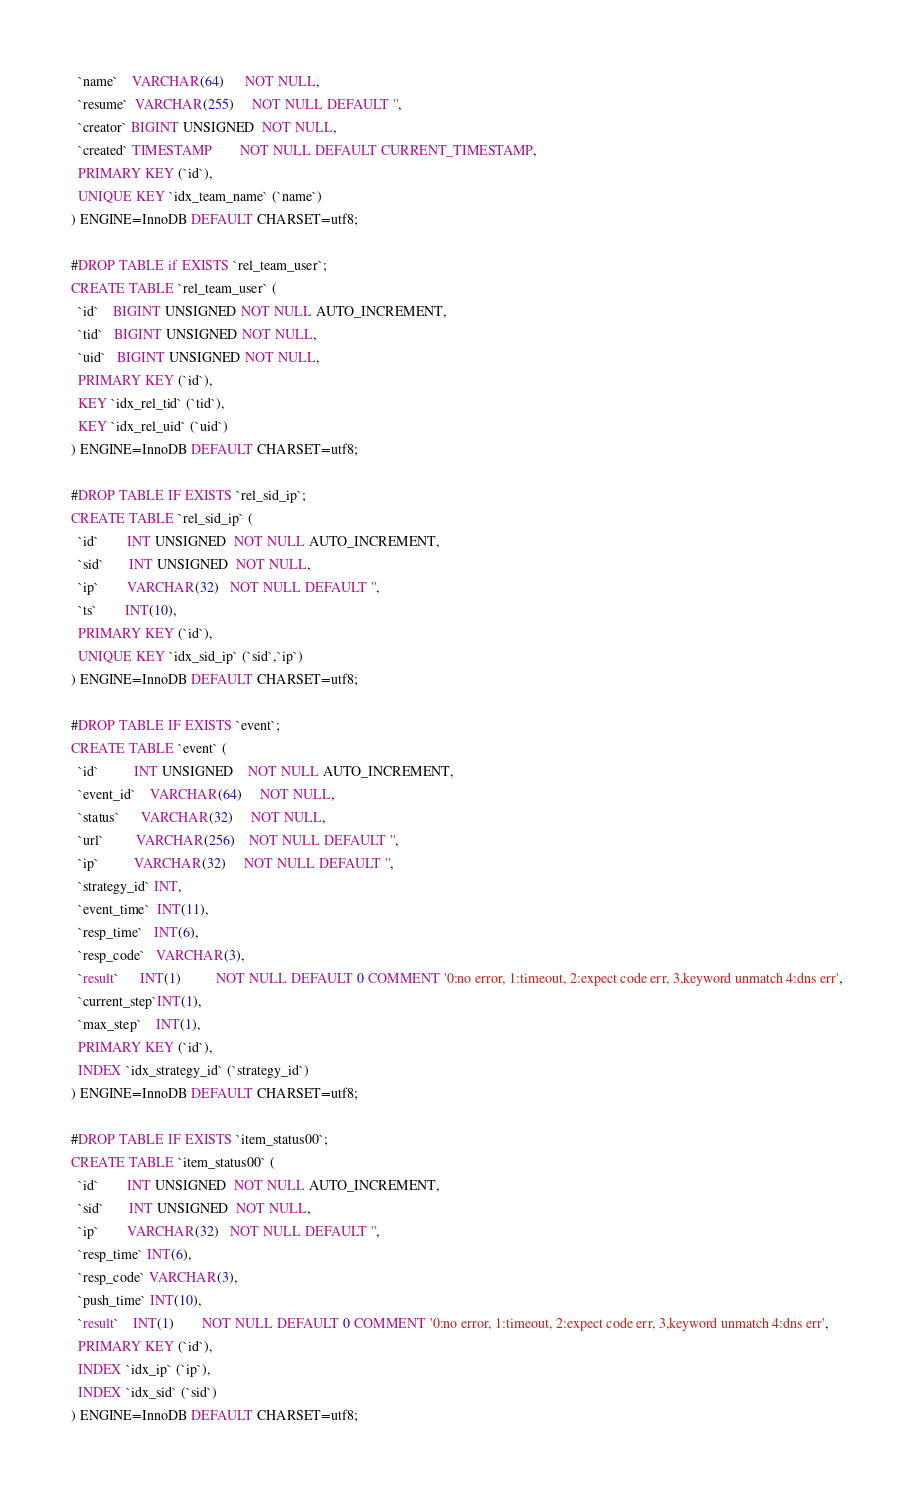Convert code to text. <code><loc_0><loc_0><loc_500><loc_500><_SQL_>  `name`    VARCHAR(64)      NOT NULL,
  `resume`  VARCHAR(255)     NOT NULL DEFAULT '',
  `creator` BIGINT UNSIGNED  NOT NULL,
  `created` TIMESTAMP        NOT NULL DEFAULT CURRENT_TIMESTAMP,
  PRIMARY KEY (`id`),
  UNIQUE KEY `idx_team_name` (`name`)
) ENGINE=InnoDB DEFAULT CHARSET=utf8;

#DROP TABLE if EXISTS `rel_team_user`;
CREATE TABLE `rel_team_user` (
  `id`    BIGINT UNSIGNED NOT NULL AUTO_INCREMENT,
  `tid`   BIGINT UNSIGNED NOT NULL,
  `uid`   BIGINT UNSIGNED NOT NULL,
  PRIMARY KEY (`id`),
  KEY `idx_rel_tid` (`tid`),
  KEY `idx_rel_uid` (`uid`)
) ENGINE=InnoDB DEFAULT CHARSET=utf8;

#DROP TABLE IF EXISTS `rel_sid_ip`;
CREATE TABLE `rel_sid_ip` (
  `id`        INT UNSIGNED  NOT NULL AUTO_INCREMENT,
  `sid`       INT UNSIGNED  NOT NULL,
  `ip`        VARCHAR(32)   NOT NULL DEFAULT '',
  `ts`        INT(10),
  PRIMARY KEY (`id`),
  UNIQUE KEY `idx_sid_ip` (`sid`,`ip`)
) ENGINE=InnoDB DEFAULT CHARSET=utf8;

#DROP TABLE IF EXISTS `event`;
CREATE TABLE `event` (
  `id`          INT UNSIGNED    NOT NULL AUTO_INCREMENT,
  `event_id`    VARCHAR(64)     NOT NULL,
  `status`      VARCHAR(32)     NOT NULL,
  `url`         VARCHAR(256)    NOT NULL DEFAULT '',
  `ip`          VARCHAR(32)     NOT NULL DEFAULT '',
  `strategy_id` INT,
  `event_time`  INT(11),
  `resp_time`   INT(6),
  `resp_code`   VARCHAR(3),
  `result`      INT(1)          NOT NULL DEFAULT 0 COMMENT '0:no error, 1:timeout, 2:expect code err, 3,keyword unmatch 4:dns err', 
  `current_step`INT(1),
  `max_step`    INT(1),
  PRIMARY KEY (`id`),
  INDEX `idx_strategy_id` (`strategy_id`)
) ENGINE=InnoDB DEFAULT CHARSET=utf8;

#DROP TABLE IF EXISTS `item_status00`;
CREATE TABLE `item_status00` (
  `id`        INT UNSIGNED  NOT NULL AUTO_INCREMENT,
  `sid`       INT UNSIGNED  NOT NULL,
  `ip`        VARCHAR(32)   NOT NULL DEFAULT '',
  `resp_time` INT(6),
  `resp_code` VARCHAR(3),
  `push_time` INT(10),
  `result`    INT(1)        NOT NULL DEFAULT 0 COMMENT '0:no error, 1:timeout, 2:expect code err, 3,keyword unmatch 4:dns err', 
  PRIMARY KEY (`id`),
  INDEX `idx_ip` (`ip`),
  INDEX `idx_sid` (`sid`)
) ENGINE=InnoDB DEFAULT CHARSET=utf8;

</code> 